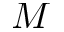<formula> <loc_0><loc_0><loc_500><loc_500>M</formula> 